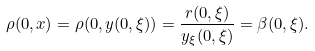Convert formula to latex. <formula><loc_0><loc_0><loc_500><loc_500>\rho ( 0 , x ) = \rho ( 0 , y ( 0 , \xi ) ) = \frac { r ( 0 , \xi ) } { y _ { \xi } ( 0 , \xi ) } = \beta ( 0 , \xi ) .</formula> 